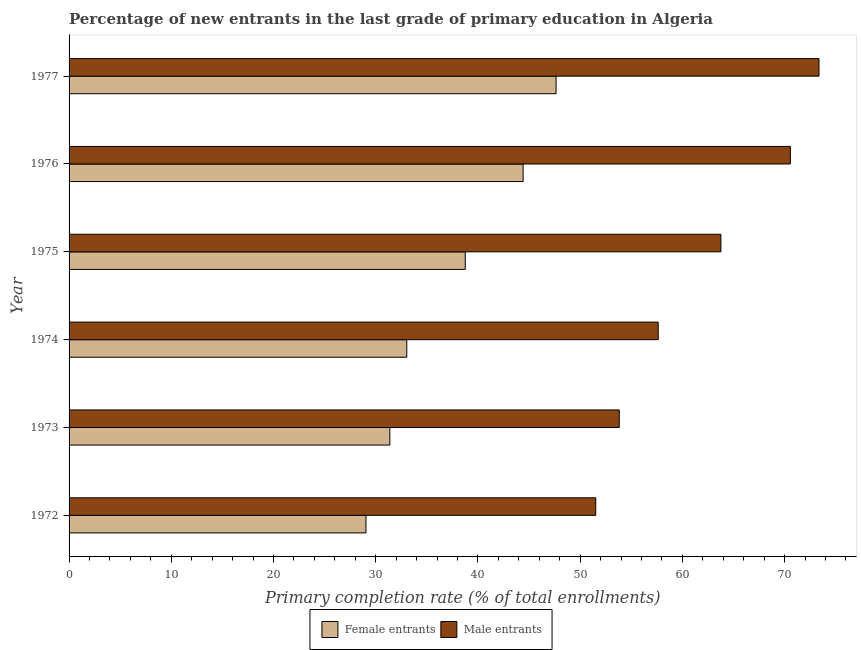How many different coloured bars are there?
Give a very brief answer. 2. Are the number of bars on each tick of the Y-axis equal?
Keep it short and to the point. Yes. How many bars are there on the 5th tick from the bottom?
Provide a succinct answer. 2. In how many cases, is the number of bars for a given year not equal to the number of legend labels?
Your answer should be compact. 0. What is the primary completion rate of male entrants in 1974?
Make the answer very short. 57.64. Across all years, what is the maximum primary completion rate of female entrants?
Provide a short and direct response. 47.64. Across all years, what is the minimum primary completion rate of female entrants?
Ensure brevity in your answer.  29.05. In which year was the primary completion rate of male entrants maximum?
Provide a short and direct response. 1977. In which year was the primary completion rate of female entrants minimum?
Give a very brief answer. 1972. What is the total primary completion rate of female entrants in the graph?
Keep it short and to the point. 224.29. What is the difference between the primary completion rate of female entrants in 1972 and that in 1973?
Provide a short and direct response. -2.33. What is the difference between the primary completion rate of male entrants in 1973 and the primary completion rate of female entrants in 1977?
Your answer should be very brief. 6.18. What is the average primary completion rate of male entrants per year?
Offer a terse response. 61.78. In the year 1974, what is the difference between the primary completion rate of female entrants and primary completion rate of male entrants?
Provide a short and direct response. -24.6. In how many years, is the primary completion rate of male entrants greater than 28 %?
Provide a succinct answer. 6. What is the ratio of the primary completion rate of male entrants in 1972 to that in 1976?
Provide a short and direct response. 0.73. Is the primary completion rate of female entrants in 1974 less than that in 1975?
Your answer should be very brief. Yes. What is the difference between the highest and the second highest primary completion rate of male entrants?
Your answer should be compact. 2.8. What is the difference between the highest and the lowest primary completion rate of male entrants?
Offer a very short reply. 21.84. What does the 1st bar from the top in 1977 represents?
Ensure brevity in your answer.  Male entrants. What does the 1st bar from the bottom in 1972 represents?
Your response must be concise. Female entrants. How many bars are there?
Offer a very short reply. 12. How many years are there in the graph?
Provide a short and direct response. 6. What is the difference between two consecutive major ticks on the X-axis?
Offer a terse response. 10. Are the values on the major ticks of X-axis written in scientific E-notation?
Your response must be concise. No. How many legend labels are there?
Provide a succinct answer. 2. What is the title of the graph?
Your answer should be very brief. Percentage of new entrants in the last grade of primary education in Algeria. Does "GDP" appear as one of the legend labels in the graph?
Ensure brevity in your answer.  No. What is the label or title of the X-axis?
Make the answer very short. Primary completion rate (% of total enrollments). What is the Primary completion rate (% of total enrollments) in Female entrants in 1972?
Provide a short and direct response. 29.05. What is the Primary completion rate (% of total enrollments) of Male entrants in 1972?
Provide a succinct answer. 51.52. What is the Primary completion rate (% of total enrollments) in Female entrants in 1973?
Make the answer very short. 31.38. What is the Primary completion rate (% of total enrollments) of Male entrants in 1973?
Give a very brief answer. 53.83. What is the Primary completion rate (% of total enrollments) of Female entrants in 1974?
Offer a very short reply. 33.04. What is the Primary completion rate (% of total enrollments) in Male entrants in 1974?
Make the answer very short. 57.64. What is the Primary completion rate (% of total enrollments) of Female entrants in 1975?
Your response must be concise. 38.76. What is the Primary completion rate (% of total enrollments) of Male entrants in 1975?
Provide a succinct answer. 63.77. What is the Primary completion rate (% of total enrollments) of Female entrants in 1976?
Keep it short and to the point. 44.42. What is the Primary completion rate (% of total enrollments) of Male entrants in 1976?
Your answer should be very brief. 70.56. What is the Primary completion rate (% of total enrollments) of Female entrants in 1977?
Offer a terse response. 47.64. What is the Primary completion rate (% of total enrollments) of Male entrants in 1977?
Offer a terse response. 73.37. Across all years, what is the maximum Primary completion rate (% of total enrollments) in Female entrants?
Provide a succinct answer. 47.64. Across all years, what is the maximum Primary completion rate (% of total enrollments) of Male entrants?
Your response must be concise. 73.37. Across all years, what is the minimum Primary completion rate (% of total enrollments) in Female entrants?
Offer a very short reply. 29.05. Across all years, what is the minimum Primary completion rate (% of total enrollments) of Male entrants?
Give a very brief answer. 51.52. What is the total Primary completion rate (% of total enrollments) in Female entrants in the graph?
Keep it short and to the point. 224.29. What is the total Primary completion rate (% of total enrollments) in Male entrants in the graph?
Give a very brief answer. 370.69. What is the difference between the Primary completion rate (% of total enrollments) of Female entrants in 1972 and that in 1973?
Ensure brevity in your answer.  -2.33. What is the difference between the Primary completion rate (% of total enrollments) of Male entrants in 1972 and that in 1973?
Ensure brevity in your answer.  -2.3. What is the difference between the Primary completion rate (% of total enrollments) in Female entrants in 1972 and that in 1974?
Provide a short and direct response. -3.99. What is the difference between the Primary completion rate (% of total enrollments) in Male entrants in 1972 and that in 1974?
Make the answer very short. -6.11. What is the difference between the Primary completion rate (% of total enrollments) of Female entrants in 1972 and that in 1975?
Your answer should be very brief. -9.71. What is the difference between the Primary completion rate (% of total enrollments) in Male entrants in 1972 and that in 1975?
Ensure brevity in your answer.  -12.25. What is the difference between the Primary completion rate (% of total enrollments) of Female entrants in 1972 and that in 1976?
Your answer should be very brief. -15.37. What is the difference between the Primary completion rate (% of total enrollments) in Male entrants in 1972 and that in 1976?
Offer a terse response. -19.04. What is the difference between the Primary completion rate (% of total enrollments) of Female entrants in 1972 and that in 1977?
Your response must be concise. -18.6. What is the difference between the Primary completion rate (% of total enrollments) of Male entrants in 1972 and that in 1977?
Your answer should be very brief. -21.84. What is the difference between the Primary completion rate (% of total enrollments) of Female entrants in 1973 and that in 1974?
Offer a terse response. -1.66. What is the difference between the Primary completion rate (% of total enrollments) of Male entrants in 1973 and that in 1974?
Make the answer very short. -3.81. What is the difference between the Primary completion rate (% of total enrollments) of Female entrants in 1973 and that in 1975?
Give a very brief answer. -7.38. What is the difference between the Primary completion rate (% of total enrollments) in Male entrants in 1973 and that in 1975?
Offer a very short reply. -9.94. What is the difference between the Primary completion rate (% of total enrollments) of Female entrants in 1973 and that in 1976?
Your answer should be very brief. -13.04. What is the difference between the Primary completion rate (% of total enrollments) in Male entrants in 1973 and that in 1976?
Offer a terse response. -16.74. What is the difference between the Primary completion rate (% of total enrollments) of Female entrants in 1973 and that in 1977?
Your answer should be very brief. -16.26. What is the difference between the Primary completion rate (% of total enrollments) in Male entrants in 1973 and that in 1977?
Your response must be concise. -19.54. What is the difference between the Primary completion rate (% of total enrollments) in Female entrants in 1974 and that in 1975?
Your answer should be very brief. -5.72. What is the difference between the Primary completion rate (% of total enrollments) of Male entrants in 1974 and that in 1975?
Provide a short and direct response. -6.13. What is the difference between the Primary completion rate (% of total enrollments) in Female entrants in 1974 and that in 1976?
Make the answer very short. -11.38. What is the difference between the Primary completion rate (% of total enrollments) of Male entrants in 1974 and that in 1976?
Keep it short and to the point. -12.93. What is the difference between the Primary completion rate (% of total enrollments) of Female entrants in 1974 and that in 1977?
Give a very brief answer. -14.61. What is the difference between the Primary completion rate (% of total enrollments) of Male entrants in 1974 and that in 1977?
Give a very brief answer. -15.73. What is the difference between the Primary completion rate (% of total enrollments) in Female entrants in 1975 and that in 1976?
Keep it short and to the point. -5.66. What is the difference between the Primary completion rate (% of total enrollments) in Male entrants in 1975 and that in 1976?
Keep it short and to the point. -6.79. What is the difference between the Primary completion rate (% of total enrollments) in Female entrants in 1975 and that in 1977?
Make the answer very short. -8.88. What is the difference between the Primary completion rate (% of total enrollments) in Male entrants in 1975 and that in 1977?
Offer a very short reply. -9.59. What is the difference between the Primary completion rate (% of total enrollments) in Female entrants in 1976 and that in 1977?
Your answer should be very brief. -3.22. What is the difference between the Primary completion rate (% of total enrollments) of Male entrants in 1976 and that in 1977?
Ensure brevity in your answer.  -2.8. What is the difference between the Primary completion rate (% of total enrollments) in Female entrants in 1972 and the Primary completion rate (% of total enrollments) in Male entrants in 1973?
Your answer should be very brief. -24.78. What is the difference between the Primary completion rate (% of total enrollments) in Female entrants in 1972 and the Primary completion rate (% of total enrollments) in Male entrants in 1974?
Offer a very short reply. -28.59. What is the difference between the Primary completion rate (% of total enrollments) in Female entrants in 1972 and the Primary completion rate (% of total enrollments) in Male entrants in 1975?
Offer a terse response. -34.72. What is the difference between the Primary completion rate (% of total enrollments) of Female entrants in 1972 and the Primary completion rate (% of total enrollments) of Male entrants in 1976?
Your response must be concise. -41.52. What is the difference between the Primary completion rate (% of total enrollments) in Female entrants in 1972 and the Primary completion rate (% of total enrollments) in Male entrants in 1977?
Your answer should be compact. -44.32. What is the difference between the Primary completion rate (% of total enrollments) of Female entrants in 1973 and the Primary completion rate (% of total enrollments) of Male entrants in 1974?
Your answer should be very brief. -26.26. What is the difference between the Primary completion rate (% of total enrollments) in Female entrants in 1973 and the Primary completion rate (% of total enrollments) in Male entrants in 1975?
Your answer should be very brief. -32.39. What is the difference between the Primary completion rate (% of total enrollments) in Female entrants in 1973 and the Primary completion rate (% of total enrollments) in Male entrants in 1976?
Keep it short and to the point. -39.18. What is the difference between the Primary completion rate (% of total enrollments) in Female entrants in 1973 and the Primary completion rate (% of total enrollments) in Male entrants in 1977?
Your answer should be compact. -41.98. What is the difference between the Primary completion rate (% of total enrollments) of Female entrants in 1974 and the Primary completion rate (% of total enrollments) of Male entrants in 1975?
Make the answer very short. -30.73. What is the difference between the Primary completion rate (% of total enrollments) of Female entrants in 1974 and the Primary completion rate (% of total enrollments) of Male entrants in 1976?
Your response must be concise. -37.53. What is the difference between the Primary completion rate (% of total enrollments) of Female entrants in 1974 and the Primary completion rate (% of total enrollments) of Male entrants in 1977?
Your answer should be very brief. -40.33. What is the difference between the Primary completion rate (% of total enrollments) in Female entrants in 1975 and the Primary completion rate (% of total enrollments) in Male entrants in 1976?
Keep it short and to the point. -31.8. What is the difference between the Primary completion rate (% of total enrollments) in Female entrants in 1975 and the Primary completion rate (% of total enrollments) in Male entrants in 1977?
Provide a short and direct response. -34.61. What is the difference between the Primary completion rate (% of total enrollments) of Female entrants in 1976 and the Primary completion rate (% of total enrollments) of Male entrants in 1977?
Provide a succinct answer. -28.95. What is the average Primary completion rate (% of total enrollments) in Female entrants per year?
Provide a short and direct response. 37.38. What is the average Primary completion rate (% of total enrollments) in Male entrants per year?
Give a very brief answer. 61.78. In the year 1972, what is the difference between the Primary completion rate (% of total enrollments) of Female entrants and Primary completion rate (% of total enrollments) of Male entrants?
Provide a short and direct response. -22.48. In the year 1973, what is the difference between the Primary completion rate (% of total enrollments) in Female entrants and Primary completion rate (% of total enrollments) in Male entrants?
Offer a very short reply. -22.45. In the year 1974, what is the difference between the Primary completion rate (% of total enrollments) in Female entrants and Primary completion rate (% of total enrollments) in Male entrants?
Offer a terse response. -24.6. In the year 1975, what is the difference between the Primary completion rate (% of total enrollments) in Female entrants and Primary completion rate (% of total enrollments) in Male entrants?
Offer a terse response. -25.01. In the year 1976, what is the difference between the Primary completion rate (% of total enrollments) in Female entrants and Primary completion rate (% of total enrollments) in Male entrants?
Offer a very short reply. -26.14. In the year 1977, what is the difference between the Primary completion rate (% of total enrollments) in Female entrants and Primary completion rate (% of total enrollments) in Male entrants?
Your answer should be compact. -25.72. What is the ratio of the Primary completion rate (% of total enrollments) of Female entrants in 1972 to that in 1973?
Provide a succinct answer. 0.93. What is the ratio of the Primary completion rate (% of total enrollments) of Male entrants in 1972 to that in 1973?
Provide a succinct answer. 0.96. What is the ratio of the Primary completion rate (% of total enrollments) in Female entrants in 1972 to that in 1974?
Offer a very short reply. 0.88. What is the ratio of the Primary completion rate (% of total enrollments) of Male entrants in 1972 to that in 1974?
Ensure brevity in your answer.  0.89. What is the ratio of the Primary completion rate (% of total enrollments) in Female entrants in 1972 to that in 1975?
Provide a succinct answer. 0.75. What is the ratio of the Primary completion rate (% of total enrollments) in Male entrants in 1972 to that in 1975?
Your answer should be very brief. 0.81. What is the ratio of the Primary completion rate (% of total enrollments) in Female entrants in 1972 to that in 1976?
Your answer should be very brief. 0.65. What is the ratio of the Primary completion rate (% of total enrollments) in Male entrants in 1972 to that in 1976?
Offer a very short reply. 0.73. What is the ratio of the Primary completion rate (% of total enrollments) of Female entrants in 1972 to that in 1977?
Your answer should be very brief. 0.61. What is the ratio of the Primary completion rate (% of total enrollments) of Male entrants in 1972 to that in 1977?
Offer a terse response. 0.7. What is the ratio of the Primary completion rate (% of total enrollments) in Female entrants in 1973 to that in 1974?
Your response must be concise. 0.95. What is the ratio of the Primary completion rate (% of total enrollments) of Male entrants in 1973 to that in 1974?
Your answer should be compact. 0.93. What is the ratio of the Primary completion rate (% of total enrollments) in Female entrants in 1973 to that in 1975?
Ensure brevity in your answer.  0.81. What is the ratio of the Primary completion rate (% of total enrollments) in Male entrants in 1973 to that in 1975?
Your answer should be compact. 0.84. What is the ratio of the Primary completion rate (% of total enrollments) in Female entrants in 1973 to that in 1976?
Your answer should be compact. 0.71. What is the ratio of the Primary completion rate (% of total enrollments) in Male entrants in 1973 to that in 1976?
Your answer should be very brief. 0.76. What is the ratio of the Primary completion rate (% of total enrollments) of Female entrants in 1973 to that in 1977?
Make the answer very short. 0.66. What is the ratio of the Primary completion rate (% of total enrollments) in Male entrants in 1973 to that in 1977?
Make the answer very short. 0.73. What is the ratio of the Primary completion rate (% of total enrollments) of Female entrants in 1974 to that in 1975?
Make the answer very short. 0.85. What is the ratio of the Primary completion rate (% of total enrollments) of Male entrants in 1974 to that in 1975?
Provide a short and direct response. 0.9. What is the ratio of the Primary completion rate (% of total enrollments) in Female entrants in 1974 to that in 1976?
Give a very brief answer. 0.74. What is the ratio of the Primary completion rate (% of total enrollments) of Male entrants in 1974 to that in 1976?
Offer a terse response. 0.82. What is the ratio of the Primary completion rate (% of total enrollments) in Female entrants in 1974 to that in 1977?
Ensure brevity in your answer.  0.69. What is the ratio of the Primary completion rate (% of total enrollments) of Male entrants in 1974 to that in 1977?
Give a very brief answer. 0.79. What is the ratio of the Primary completion rate (% of total enrollments) of Female entrants in 1975 to that in 1976?
Make the answer very short. 0.87. What is the ratio of the Primary completion rate (% of total enrollments) in Male entrants in 1975 to that in 1976?
Make the answer very short. 0.9. What is the ratio of the Primary completion rate (% of total enrollments) of Female entrants in 1975 to that in 1977?
Offer a very short reply. 0.81. What is the ratio of the Primary completion rate (% of total enrollments) in Male entrants in 1975 to that in 1977?
Offer a very short reply. 0.87. What is the ratio of the Primary completion rate (% of total enrollments) of Female entrants in 1976 to that in 1977?
Ensure brevity in your answer.  0.93. What is the ratio of the Primary completion rate (% of total enrollments) of Male entrants in 1976 to that in 1977?
Provide a short and direct response. 0.96. What is the difference between the highest and the second highest Primary completion rate (% of total enrollments) in Female entrants?
Ensure brevity in your answer.  3.22. What is the difference between the highest and the second highest Primary completion rate (% of total enrollments) in Male entrants?
Give a very brief answer. 2.8. What is the difference between the highest and the lowest Primary completion rate (% of total enrollments) in Female entrants?
Offer a terse response. 18.6. What is the difference between the highest and the lowest Primary completion rate (% of total enrollments) in Male entrants?
Offer a terse response. 21.84. 